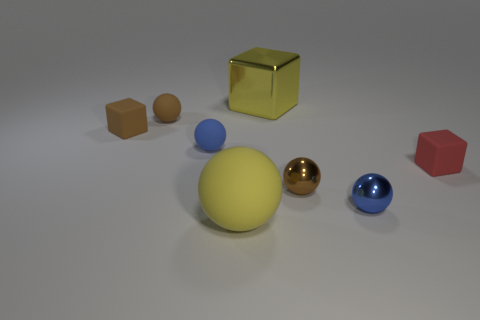Subtract all tiny blue metal balls. How many balls are left? 4 Subtract all green spheres. Subtract all blue cylinders. How many spheres are left? 5 Add 2 purple metallic cubes. How many objects exist? 10 Subtract all blocks. How many objects are left? 5 Add 4 blocks. How many blocks are left? 7 Add 6 big cyan metal things. How many big cyan metal things exist? 6 Subtract 1 brown blocks. How many objects are left? 7 Subtract all large gray metallic spheres. Subtract all blue metallic things. How many objects are left? 7 